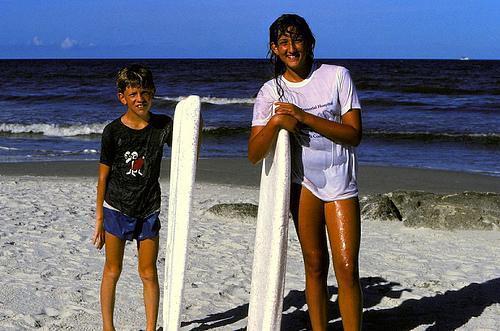How many surfers are shown?
Give a very brief answer. 2. How many boats are on the horizon?
Give a very brief answer. 1. How many waves are cresting?
Give a very brief answer. 2. How many people are in the photo?
Give a very brief answer. 2. How many surfboards are in the photo?
Give a very brief answer. 2. How many people are visible?
Give a very brief answer. 2. How many surfboards are visible?
Give a very brief answer. 2. 